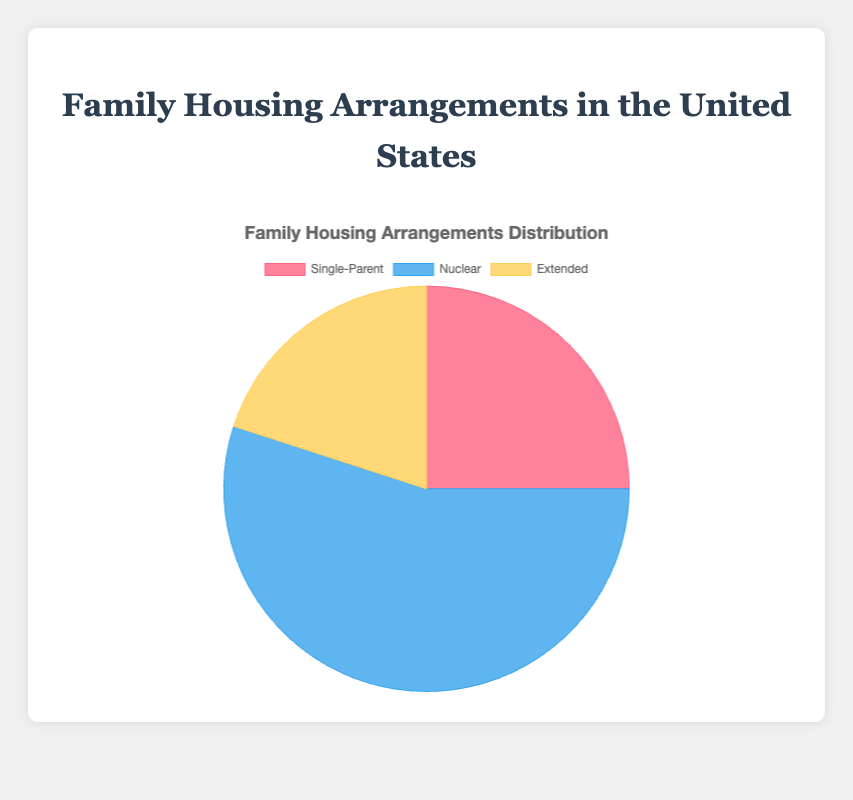What is the percentage of Single-Parent families in the United States? The pie chart shows that Single-Parent families account for 25% of the total family housing arrangements in the United States.
Answer: 25% How does the percentage of Nuclear families compare to Extended families in the United States? By looking at the pie chart, we can see that Nuclear families make up 55% whereas Extended families make up 20%. Therefore, Nuclear families are more prevalent than Extended families.
Answer: Nuclear > Extended Which type of family arrangement has the smallest percentage in the United States? The pie chart indicates that the Extended family arrangement has the smallest percentage at 20%.
Answer: Extended What is the total percentage of family housing arrangements that are either Single-Parent or Nuclear in the United States? To find the total percentage, add the percentages of Single-Parent (25%) and Nuclear (55%) families. 25% + 55% = 80%
Answer: 80% What is the difference in percentage between Single-Parent and Nuclear families in the United States? Subtract the percentage of Single-Parent families (25%) from the percentage of Nuclear families (55%). 55% - 25% = 30%
Answer: 30% Which segment has a greater percentage in the United States, Extended families or Single-Parent families? According to the pie chart, Single-Parent families account for 25% of the population, whereas Extended families account for 20%, making Single-Parent families more prevalent.
Answer: Single-Parent > Extended In terms of visual representation, which color represents the largest segment in the pie chart? The chart uses blue to represent the Nuclear family, which is the largest segment at 55%.
Answer: Blue 